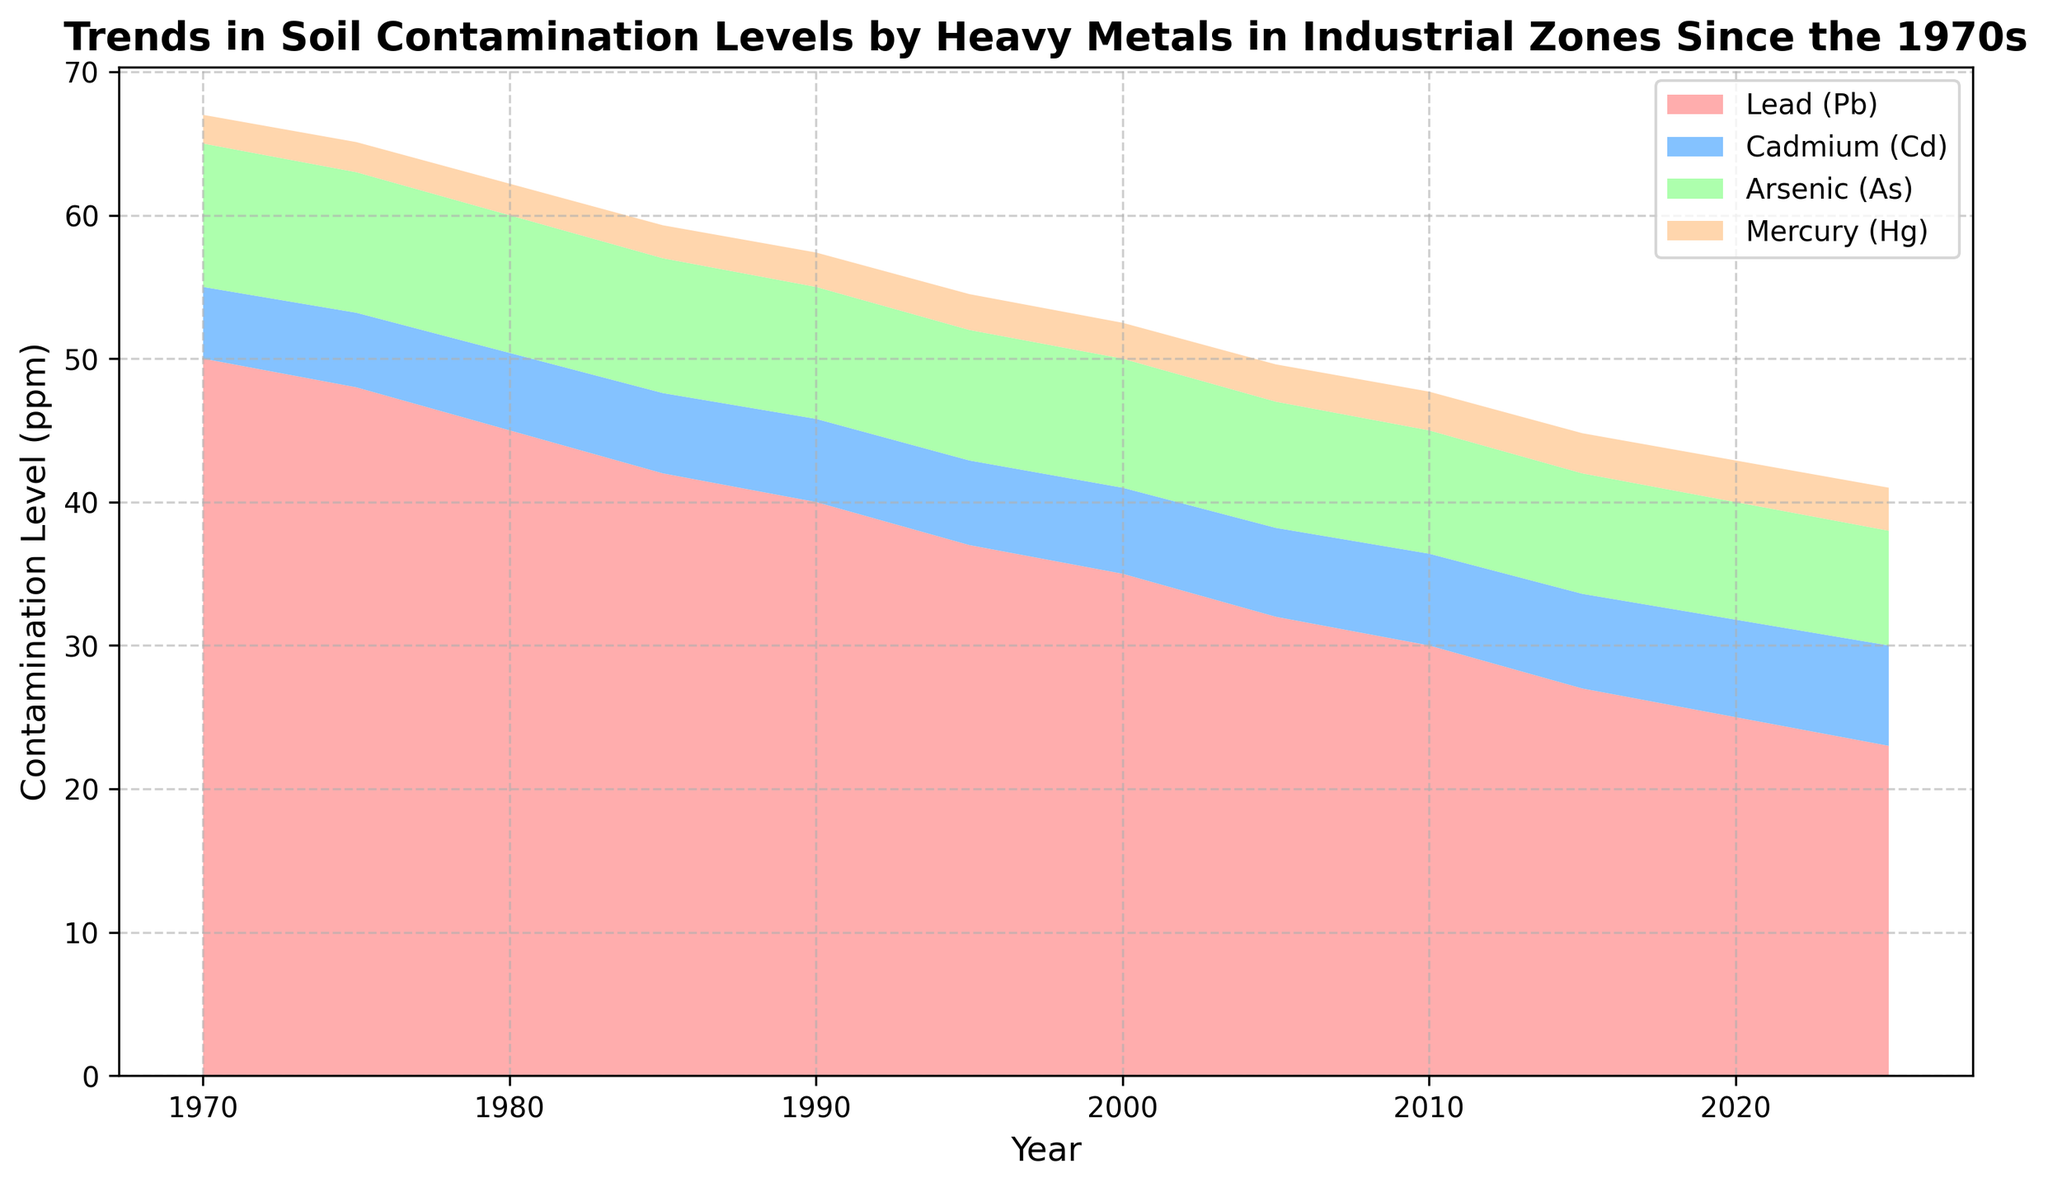What year did Lead (Pb) in soil contamination drop to its lowest point? By examining the area chart, look for the year in which the area representing Lead (Pb) contamination is at its lowest height, which corresponds to the last year in the dataset.
Answer: 2025 Which heavy metal shows an increasing trend over the years? Analyze the area chart to identify which heavy metal's area consistently increases in height from 1970 to 2025.
Answer: Cadmium (Cd) Compare the contamination levels of Lead (Pb) and Mercury (Hg) in 1990. Which one is higher and by how much? Use the area chart to find the heights representing Lead (Pb) and Mercury (Hg) in 1990. Lead (Pb) is at 40 ppm, and Mercury (Hg) is at 2.4 ppm. Subtract the contamination level of Mercury (Hg) from that of Lead (Pb).
Answer: Lead (Pb) is higher by 37.6 ppm What is the total contamination level in soil for the year 2010? Add the contamination levels for Lead (Pb), Cadmium (Cd), Arsenic (As), and Mercury (Hg) for the year 2010. The values are 30, 6.4, 8.6, and 2.7, respectively. So, 30 + 6.4 + 8.6 + 2.7 = 47.7 ppm.
Answer: 47.7 ppm Compare the trends for Lead (Pb) and Arsenic (As) since 1970. Do they both show a decreasing trend? Examine the trends in the area chart for both Lead (Pb) and Arsenic (As) from 1970 to 2025. Verify if the height representing each metal decreases over the years.
Answer: Yes, both show a decreasing trend Which year shows the highest contamination level for Cadmium (Cd), and what is the value? Look at the area chart to find the year when the height for Cadmium (Cd) is at its tallest, which corresponds to its highest value of contamination.
Answer: 2025, 7 ppm How does the contamination of Mercury (Hg) change from 1970 to 2025? Use the area chart to compare the height representing Mercury (Hg) in 1970 and 2025. In 1970, it is 2 ppm, and in 2025, it is 3 ppm, indicating an increase.
Answer: Increases by 1 ppm What is the average contamination level of Lead (Pb) across the entire period from 1970 to 2025? Sum the contamination levels of Lead (Pb) for each year, then divide by the number of years. (50+48+45+42+40+37+35+32+30+27+25+23)/12 = 32.83 ppm.
Answer: 32.83 ppm Which heavy metal has the smallest variation in contamination levels over the years? By examining the area chart, notice that Mercury (Hg) has the smallest difference in height, indicating the smallest variation in contamination levels since 1970.
Answer: Mercury (Hg) Between 2005 and 2015, which heavy metal shows the greatest decrease in contamination level in the soil? Analyze the difference in heights from 2005 to 2015 for each metal. Lead (Pb) shows the greatest decrease from 32 to 27 ppm, a drop of 5 ppm.
Answer: Lead (Pb) 